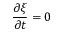<formula> <loc_0><loc_0><loc_500><loc_500>\frac { \partial \xi } { \partial t } = 0</formula> 